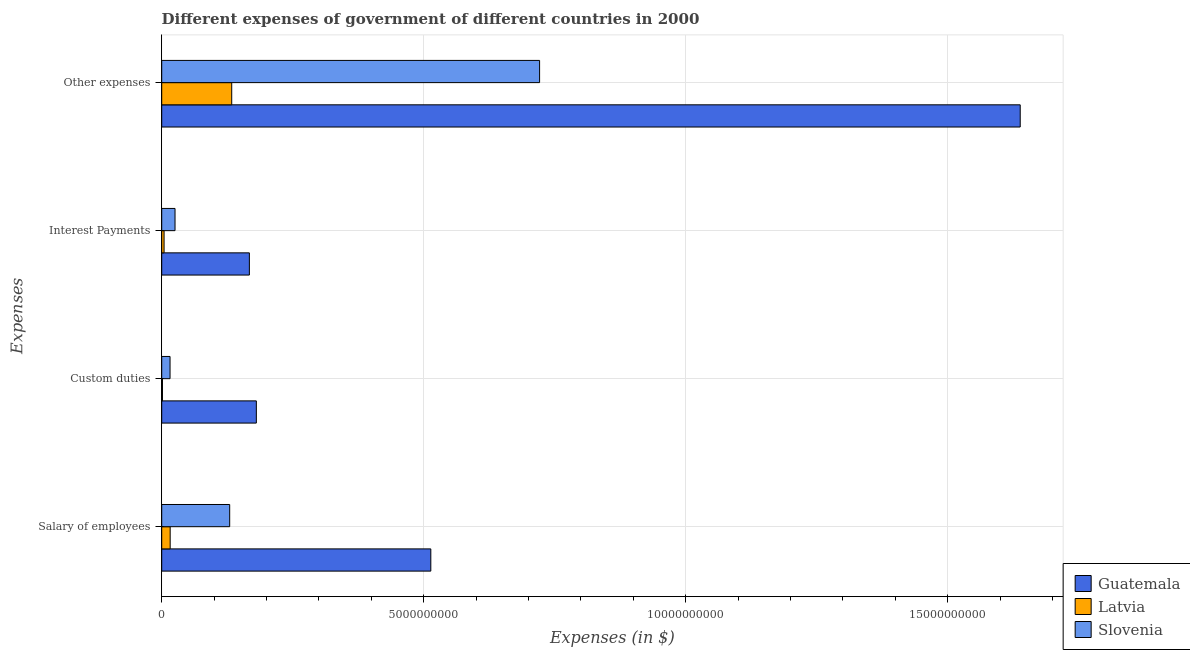Are the number of bars per tick equal to the number of legend labels?
Your answer should be very brief. Yes. What is the label of the 1st group of bars from the top?
Your answer should be compact. Other expenses. What is the amount spent on salary of employees in Slovenia?
Keep it short and to the point. 1.30e+09. Across all countries, what is the maximum amount spent on custom duties?
Ensure brevity in your answer.  1.81e+09. Across all countries, what is the minimum amount spent on other expenses?
Your answer should be very brief. 1.34e+09. In which country was the amount spent on interest payments maximum?
Your answer should be compact. Guatemala. In which country was the amount spent on interest payments minimum?
Provide a succinct answer. Latvia. What is the total amount spent on salary of employees in the graph?
Your answer should be very brief. 6.59e+09. What is the difference between the amount spent on interest payments in Slovenia and that in Guatemala?
Your answer should be very brief. -1.42e+09. What is the difference between the amount spent on interest payments in Guatemala and the amount spent on salary of employees in Slovenia?
Make the answer very short. 3.76e+08. What is the average amount spent on salary of employees per country?
Offer a terse response. 2.20e+09. What is the difference between the amount spent on salary of employees and amount spent on interest payments in Slovenia?
Provide a succinct answer. 1.04e+09. What is the ratio of the amount spent on salary of employees in Slovenia to that in Latvia?
Offer a very short reply. 8.04. Is the amount spent on custom duties in Latvia less than that in Slovenia?
Keep it short and to the point. Yes. What is the difference between the highest and the second highest amount spent on custom duties?
Offer a terse response. 1.65e+09. What is the difference between the highest and the lowest amount spent on interest payments?
Provide a succinct answer. 1.63e+09. In how many countries, is the amount spent on other expenses greater than the average amount spent on other expenses taken over all countries?
Your answer should be compact. 1. Is the sum of the amount spent on salary of employees in Latvia and Slovenia greater than the maximum amount spent on interest payments across all countries?
Provide a succinct answer. No. Is it the case that in every country, the sum of the amount spent on salary of employees and amount spent on custom duties is greater than the sum of amount spent on interest payments and amount spent on other expenses?
Provide a short and direct response. No. What does the 1st bar from the top in Salary of employees represents?
Provide a short and direct response. Slovenia. What does the 2nd bar from the bottom in Custom duties represents?
Your response must be concise. Latvia. Is it the case that in every country, the sum of the amount spent on salary of employees and amount spent on custom duties is greater than the amount spent on interest payments?
Provide a succinct answer. Yes. How many bars are there?
Make the answer very short. 12. Are all the bars in the graph horizontal?
Your answer should be very brief. Yes. How many countries are there in the graph?
Give a very brief answer. 3. Does the graph contain grids?
Offer a very short reply. Yes. How many legend labels are there?
Provide a succinct answer. 3. What is the title of the graph?
Provide a succinct answer. Different expenses of government of different countries in 2000. Does "South Asia" appear as one of the legend labels in the graph?
Keep it short and to the point. No. What is the label or title of the X-axis?
Offer a terse response. Expenses (in $). What is the label or title of the Y-axis?
Your answer should be very brief. Expenses. What is the Expenses (in $) of Guatemala in Salary of employees?
Your answer should be compact. 5.13e+09. What is the Expenses (in $) of Latvia in Salary of employees?
Provide a succinct answer. 1.61e+08. What is the Expenses (in $) of Slovenia in Salary of employees?
Provide a short and direct response. 1.30e+09. What is the Expenses (in $) of Guatemala in Custom duties?
Keep it short and to the point. 1.81e+09. What is the Expenses (in $) of Latvia in Custom duties?
Offer a terse response. 1.44e+07. What is the Expenses (in $) of Slovenia in Custom duties?
Your answer should be compact. 1.59e+08. What is the Expenses (in $) in Guatemala in Interest Payments?
Give a very brief answer. 1.67e+09. What is the Expenses (in $) of Latvia in Interest Payments?
Provide a succinct answer. 4.52e+07. What is the Expenses (in $) of Slovenia in Interest Payments?
Your answer should be very brief. 2.54e+08. What is the Expenses (in $) of Guatemala in Other expenses?
Give a very brief answer. 1.64e+1. What is the Expenses (in $) in Latvia in Other expenses?
Make the answer very short. 1.34e+09. What is the Expenses (in $) of Slovenia in Other expenses?
Make the answer very short. 7.21e+09. Across all Expenses, what is the maximum Expenses (in $) of Guatemala?
Make the answer very short. 1.64e+1. Across all Expenses, what is the maximum Expenses (in $) of Latvia?
Your response must be concise. 1.34e+09. Across all Expenses, what is the maximum Expenses (in $) of Slovenia?
Provide a short and direct response. 7.21e+09. Across all Expenses, what is the minimum Expenses (in $) in Guatemala?
Keep it short and to the point. 1.67e+09. Across all Expenses, what is the minimum Expenses (in $) of Latvia?
Keep it short and to the point. 1.44e+07. Across all Expenses, what is the minimum Expenses (in $) in Slovenia?
Offer a terse response. 1.59e+08. What is the total Expenses (in $) of Guatemala in the graph?
Make the answer very short. 2.50e+1. What is the total Expenses (in $) in Latvia in the graph?
Provide a succinct answer. 1.56e+09. What is the total Expenses (in $) in Slovenia in the graph?
Make the answer very short. 8.92e+09. What is the difference between the Expenses (in $) of Guatemala in Salary of employees and that in Custom duties?
Make the answer very short. 3.33e+09. What is the difference between the Expenses (in $) of Latvia in Salary of employees and that in Custom duties?
Ensure brevity in your answer.  1.47e+08. What is the difference between the Expenses (in $) of Slovenia in Salary of employees and that in Custom duties?
Ensure brevity in your answer.  1.14e+09. What is the difference between the Expenses (in $) of Guatemala in Salary of employees and that in Interest Payments?
Your answer should be very brief. 3.46e+09. What is the difference between the Expenses (in $) of Latvia in Salary of employees and that in Interest Payments?
Ensure brevity in your answer.  1.16e+08. What is the difference between the Expenses (in $) of Slovenia in Salary of employees and that in Interest Payments?
Give a very brief answer. 1.04e+09. What is the difference between the Expenses (in $) in Guatemala in Salary of employees and that in Other expenses?
Keep it short and to the point. -1.12e+1. What is the difference between the Expenses (in $) of Latvia in Salary of employees and that in Other expenses?
Make the answer very short. -1.17e+09. What is the difference between the Expenses (in $) in Slovenia in Salary of employees and that in Other expenses?
Your answer should be very brief. -5.91e+09. What is the difference between the Expenses (in $) in Guatemala in Custom duties and that in Interest Payments?
Provide a succinct answer. 1.33e+08. What is the difference between the Expenses (in $) of Latvia in Custom duties and that in Interest Payments?
Offer a terse response. -3.08e+07. What is the difference between the Expenses (in $) in Slovenia in Custom duties and that in Interest Payments?
Ensure brevity in your answer.  -9.51e+07. What is the difference between the Expenses (in $) in Guatemala in Custom duties and that in Other expenses?
Give a very brief answer. -1.46e+1. What is the difference between the Expenses (in $) in Latvia in Custom duties and that in Other expenses?
Your response must be concise. -1.32e+09. What is the difference between the Expenses (in $) in Slovenia in Custom duties and that in Other expenses?
Ensure brevity in your answer.  -7.05e+09. What is the difference between the Expenses (in $) in Guatemala in Interest Payments and that in Other expenses?
Your answer should be very brief. -1.47e+1. What is the difference between the Expenses (in $) of Latvia in Interest Payments and that in Other expenses?
Make the answer very short. -1.29e+09. What is the difference between the Expenses (in $) in Slovenia in Interest Payments and that in Other expenses?
Make the answer very short. -6.96e+09. What is the difference between the Expenses (in $) in Guatemala in Salary of employees and the Expenses (in $) in Latvia in Custom duties?
Your answer should be compact. 5.12e+09. What is the difference between the Expenses (in $) in Guatemala in Salary of employees and the Expenses (in $) in Slovenia in Custom duties?
Give a very brief answer. 4.98e+09. What is the difference between the Expenses (in $) of Latvia in Salary of employees and the Expenses (in $) of Slovenia in Custom duties?
Your response must be concise. 2.38e+06. What is the difference between the Expenses (in $) of Guatemala in Salary of employees and the Expenses (in $) of Latvia in Interest Payments?
Ensure brevity in your answer.  5.09e+09. What is the difference between the Expenses (in $) of Guatemala in Salary of employees and the Expenses (in $) of Slovenia in Interest Payments?
Your response must be concise. 4.88e+09. What is the difference between the Expenses (in $) in Latvia in Salary of employees and the Expenses (in $) in Slovenia in Interest Payments?
Your answer should be compact. -9.28e+07. What is the difference between the Expenses (in $) of Guatemala in Salary of employees and the Expenses (in $) of Latvia in Other expenses?
Keep it short and to the point. 3.80e+09. What is the difference between the Expenses (in $) of Guatemala in Salary of employees and the Expenses (in $) of Slovenia in Other expenses?
Your response must be concise. -2.08e+09. What is the difference between the Expenses (in $) in Latvia in Salary of employees and the Expenses (in $) in Slovenia in Other expenses?
Provide a succinct answer. -7.05e+09. What is the difference between the Expenses (in $) of Guatemala in Custom duties and the Expenses (in $) of Latvia in Interest Payments?
Your answer should be compact. 1.76e+09. What is the difference between the Expenses (in $) of Guatemala in Custom duties and the Expenses (in $) of Slovenia in Interest Payments?
Offer a very short reply. 1.55e+09. What is the difference between the Expenses (in $) of Latvia in Custom duties and the Expenses (in $) of Slovenia in Interest Payments?
Your response must be concise. -2.40e+08. What is the difference between the Expenses (in $) of Guatemala in Custom duties and the Expenses (in $) of Latvia in Other expenses?
Your response must be concise. 4.70e+08. What is the difference between the Expenses (in $) in Guatemala in Custom duties and the Expenses (in $) in Slovenia in Other expenses?
Your answer should be very brief. -5.40e+09. What is the difference between the Expenses (in $) of Latvia in Custom duties and the Expenses (in $) of Slovenia in Other expenses?
Give a very brief answer. -7.20e+09. What is the difference between the Expenses (in $) of Guatemala in Interest Payments and the Expenses (in $) of Latvia in Other expenses?
Your response must be concise. 3.37e+08. What is the difference between the Expenses (in $) in Guatemala in Interest Payments and the Expenses (in $) in Slovenia in Other expenses?
Make the answer very short. -5.54e+09. What is the difference between the Expenses (in $) of Latvia in Interest Payments and the Expenses (in $) of Slovenia in Other expenses?
Your answer should be very brief. -7.17e+09. What is the average Expenses (in $) in Guatemala per Expenses?
Your answer should be very brief. 6.25e+09. What is the average Expenses (in $) of Latvia per Expenses?
Offer a very short reply. 3.89e+08. What is the average Expenses (in $) in Slovenia per Expenses?
Your answer should be compact. 2.23e+09. What is the difference between the Expenses (in $) of Guatemala and Expenses (in $) of Latvia in Salary of employees?
Your answer should be compact. 4.97e+09. What is the difference between the Expenses (in $) in Guatemala and Expenses (in $) in Slovenia in Salary of employees?
Keep it short and to the point. 3.84e+09. What is the difference between the Expenses (in $) of Latvia and Expenses (in $) of Slovenia in Salary of employees?
Offer a very short reply. -1.14e+09. What is the difference between the Expenses (in $) in Guatemala and Expenses (in $) in Latvia in Custom duties?
Your response must be concise. 1.79e+09. What is the difference between the Expenses (in $) of Guatemala and Expenses (in $) of Slovenia in Custom duties?
Make the answer very short. 1.65e+09. What is the difference between the Expenses (in $) of Latvia and Expenses (in $) of Slovenia in Custom duties?
Your answer should be compact. -1.45e+08. What is the difference between the Expenses (in $) of Guatemala and Expenses (in $) of Latvia in Interest Payments?
Offer a very short reply. 1.63e+09. What is the difference between the Expenses (in $) of Guatemala and Expenses (in $) of Slovenia in Interest Payments?
Give a very brief answer. 1.42e+09. What is the difference between the Expenses (in $) in Latvia and Expenses (in $) in Slovenia in Interest Payments?
Give a very brief answer. -2.09e+08. What is the difference between the Expenses (in $) in Guatemala and Expenses (in $) in Latvia in Other expenses?
Ensure brevity in your answer.  1.50e+1. What is the difference between the Expenses (in $) in Guatemala and Expenses (in $) in Slovenia in Other expenses?
Your answer should be very brief. 9.17e+09. What is the difference between the Expenses (in $) in Latvia and Expenses (in $) in Slovenia in Other expenses?
Your answer should be compact. -5.87e+09. What is the ratio of the Expenses (in $) in Guatemala in Salary of employees to that in Custom duties?
Offer a very short reply. 2.84. What is the ratio of the Expenses (in $) of Latvia in Salary of employees to that in Custom duties?
Your answer should be very brief. 11.2. What is the ratio of the Expenses (in $) of Slovenia in Salary of employees to that in Custom duties?
Offer a terse response. 8.16. What is the ratio of the Expenses (in $) of Guatemala in Salary of employees to that in Interest Payments?
Your answer should be very brief. 3.07. What is the ratio of the Expenses (in $) of Latvia in Salary of employees to that in Interest Payments?
Provide a short and direct response. 3.57. What is the ratio of the Expenses (in $) in Slovenia in Salary of employees to that in Interest Payments?
Keep it short and to the point. 5.11. What is the ratio of the Expenses (in $) in Guatemala in Salary of employees to that in Other expenses?
Your response must be concise. 0.31. What is the ratio of the Expenses (in $) in Latvia in Salary of employees to that in Other expenses?
Your response must be concise. 0.12. What is the ratio of the Expenses (in $) in Slovenia in Salary of employees to that in Other expenses?
Provide a succinct answer. 0.18. What is the ratio of the Expenses (in $) of Guatemala in Custom duties to that in Interest Payments?
Provide a succinct answer. 1.08. What is the ratio of the Expenses (in $) of Latvia in Custom duties to that in Interest Payments?
Give a very brief answer. 0.32. What is the ratio of the Expenses (in $) of Slovenia in Custom duties to that in Interest Payments?
Your response must be concise. 0.63. What is the ratio of the Expenses (in $) of Guatemala in Custom duties to that in Other expenses?
Provide a succinct answer. 0.11. What is the ratio of the Expenses (in $) in Latvia in Custom duties to that in Other expenses?
Offer a very short reply. 0.01. What is the ratio of the Expenses (in $) in Slovenia in Custom duties to that in Other expenses?
Give a very brief answer. 0.02. What is the ratio of the Expenses (in $) in Guatemala in Interest Payments to that in Other expenses?
Your answer should be very brief. 0.1. What is the ratio of the Expenses (in $) in Latvia in Interest Payments to that in Other expenses?
Give a very brief answer. 0.03. What is the ratio of the Expenses (in $) in Slovenia in Interest Payments to that in Other expenses?
Provide a succinct answer. 0.04. What is the difference between the highest and the second highest Expenses (in $) in Guatemala?
Make the answer very short. 1.12e+1. What is the difference between the highest and the second highest Expenses (in $) in Latvia?
Ensure brevity in your answer.  1.17e+09. What is the difference between the highest and the second highest Expenses (in $) in Slovenia?
Offer a terse response. 5.91e+09. What is the difference between the highest and the lowest Expenses (in $) of Guatemala?
Keep it short and to the point. 1.47e+1. What is the difference between the highest and the lowest Expenses (in $) in Latvia?
Offer a terse response. 1.32e+09. What is the difference between the highest and the lowest Expenses (in $) of Slovenia?
Ensure brevity in your answer.  7.05e+09. 